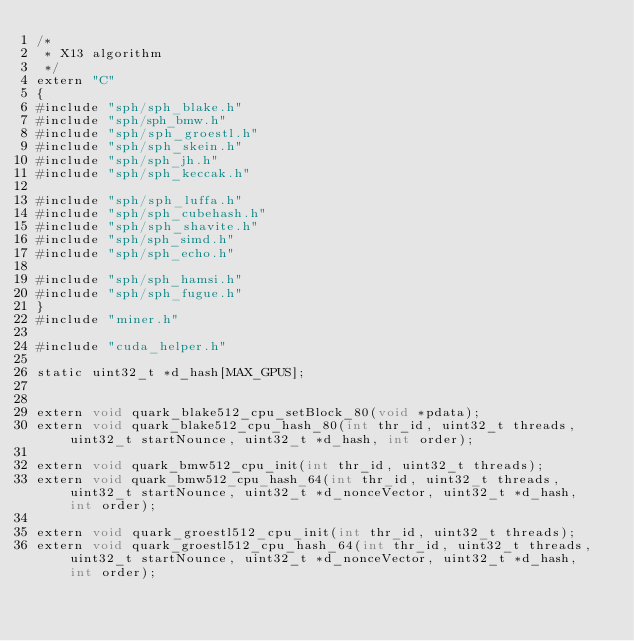Convert code to text. <code><loc_0><loc_0><loc_500><loc_500><_Cuda_>/*
 * X13 algorithm
 */
extern "C"
{
#include "sph/sph_blake.h"
#include "sph/sph_bmw.h"
#include "sph/sph_groestl.h"
#include "sph/sph_skein.h"
#include "sph/sph_jh.h"
#include "sph/sph_keccak.h"

#include "sph/sph_luffa.h"
#include "sph/sph_cubehash.h"
#include "sph/sph_shavite.h"
#include "sph/sph_simd.h"
#include "sph/sph_echo.h"

#include "sph/sph_hamsi.h"
#include "sph/sph_fugue.h"
}
#include "miner.h"

#include "cuda_helper.h"

static uint32_t *d_hash[MAX_GPUS];


extern void quark_blake512_cpu_setBlock_80(void *pdata);
extern void quark_blake512_cpu_hash_80(int thr_id, uint32_t threads, uint32_t startNounce, uint32_t *d_hash, int order);

extern void quark_bmw512_cpu_init(int thr_id, uint32_t threads);
extern void quark_bmw512_cpu_hash_64(int thr_id, uint32_t threads, uint32_t startNounce, uint32_t *d_nonceVector, uint32_t *d_hash, int order);

extern void quark_groestl512_cpu_init(int thr_id, uint32_t threads);
extern void quark_groestl512_cpu_hash_64(int thr_id, uint32_t threads, uint32_t startNounce, uint32_t *d_nonceVector, uint32_t *d_hash, int order);
</code> 